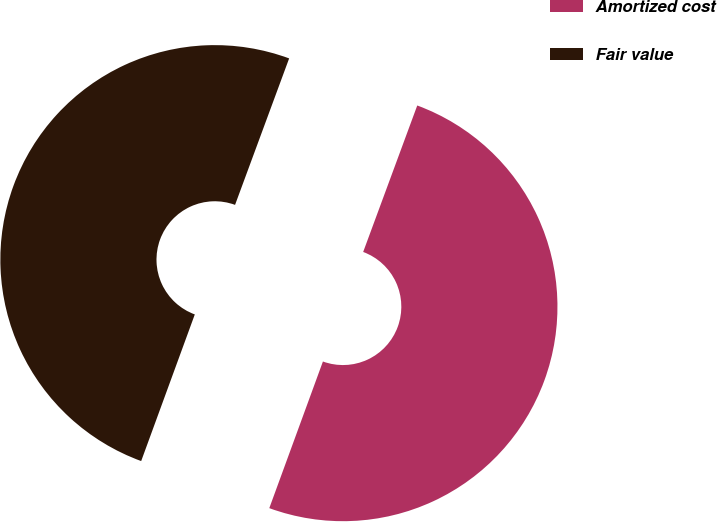<chart> <loc_0><loc_0><loc_500><loc_500><pie_chart><fcel>Amortized cost<fcel>Fair value<nl><fcel>49.95%<fcel>50.05%<nl></chart> 